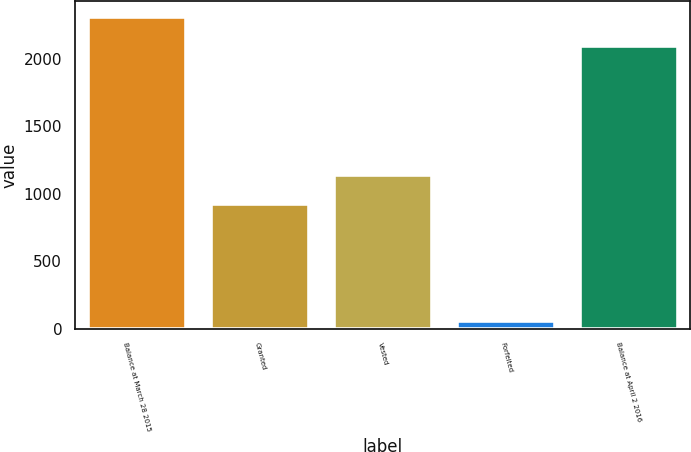Convert chart. <chart><loc_0><loc_0><loc_500><loc_500><bar_chart><fcel>Balance at March 28 2015<fcel>Granted<fcel>Vested<fcel>Forfeited<fcel>Balance at April 2 2016<nl><fcel>2309.4<fcel>923<fcel>1137.4<fcel>58<fcel>2095<nl></chart> 